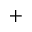<formula> <loc_0><loc_0><loc_500><loc_500>^ { + }</formula> 